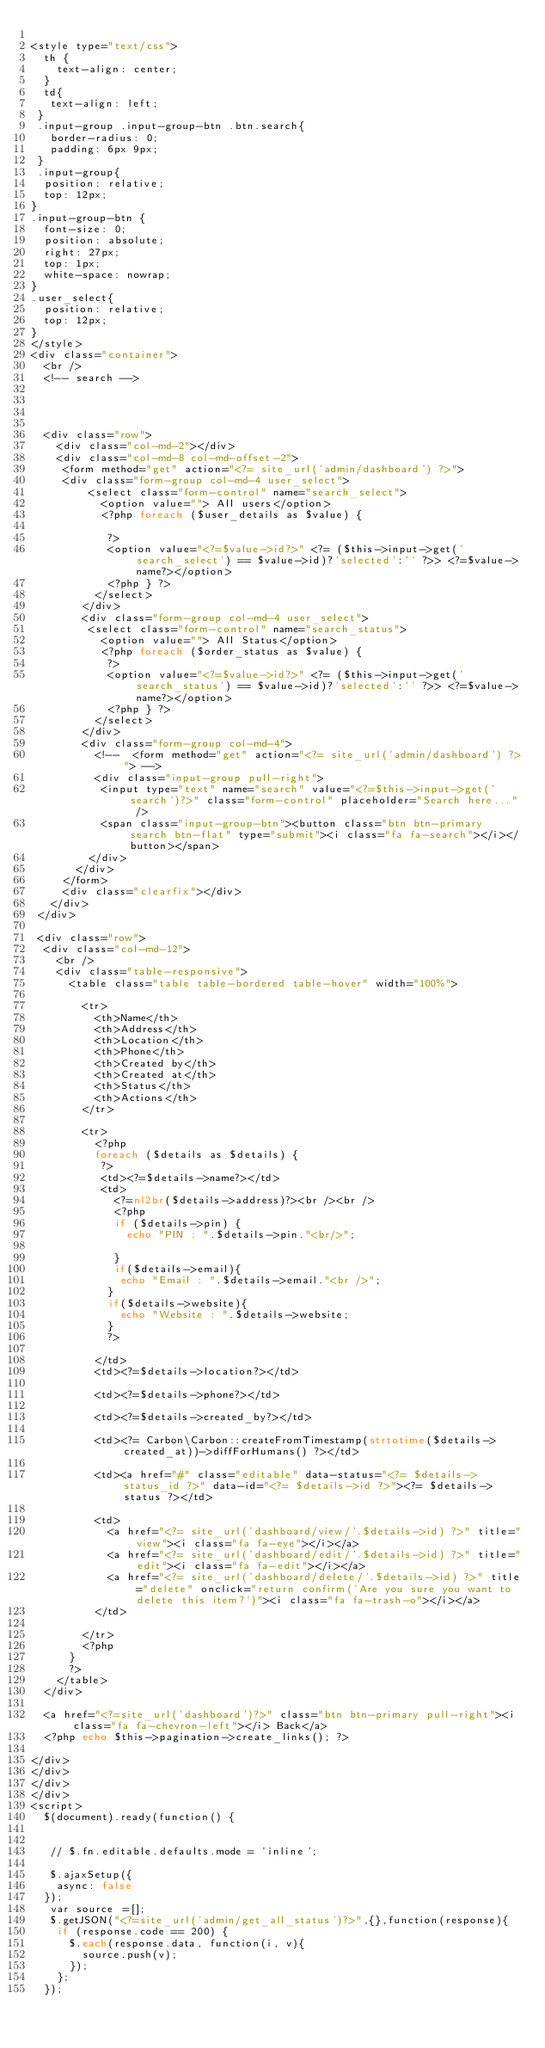<code> <loc_0><loc_0><loc_500><loc_500><_PHP_>
<style type="text/css">
  th {
    text-align: center;
  }
  td{
   text-align: left;
 }
 .input-group .input-group-btn .btn.search{
   border-radius: 0;
   padding: 6px 9px;
 }
 .input-group{
  position: relative;
  top: 12px;
}
.input-group-btn {
  font-size: 0;
  position: absolute;
  right: 27px;
  top: 1px;
  white-space: nowrap;
}
.user_select{
  position: relative;
  top: 12px;
}
</style>
<div class="container">
  <br />
  <!-- search -->




  <div class="row">
    <div class="col-md-2"></div>
    <div class="col-md-8 col-md-offset-2">
     <form method="get" action="<?= site_url('admin/dashboard') ?>">
     <div class="form-group col-md-4 user_select">
         <select class="form-control" name="search_select">
           <option value=""> All users</option>
           <?php foreach ($user_details as $value) {

            ?>
            <option value="<?=$value->id?>" <?= ($this->input->get('search_select') == $value->id)?'selected':'' ?>> <?=$value->name?></option>
            <?php } ?>
          </select>
        </div>
        <div class="form-group col-md-4 user_select">
         <select class="form-control" name="search_status">
           <option value=""> All Status</option>
           <?php foreach ($order_status as $value) {
            ?>
            <option value="<?=$value->id?>" <?= ($this->input->get('search_status') == $value->id)?'selected':'' ?>> <?=$value->name?></option>
            <?php } ?>
          </select>
        </div>
        <div class="form-group col-md-4">
          <!--  <form method="get" action="<?= site_url('admin/dashboard') ?>"> -->
          <div class="input-group pull-right">
           <input type="text" name="search" value="<?=$this->input->get('search')?>" class="form-control" placeholder="Search here..." />
           <span class="input-group-btn"><button class="btn btn-primary search btn-flat" type="submit"><i class="fa fa-search"></i></button></span>
         </div>
       </div>
     </form>
     <div class="clearfix"></div>
   </div>
 </div>

 <div class="row">
  <div class="col-md-12">
    <br />
    <div class="table-responsive">
      <table class="table table-bordered table-hover" width="100%">

        <tr>
          <th>Name</th>
          <th>Address</th>
          <th>Location</th>
          <th>Phone</th>
          <th>Created by</th>
          <th>Created at</th>
          <th>Status</th>
          <th>Actions</th>
        </tr>

        <tr>
          <?php
          foreach ($details as $details) {
           ?>
           <td><?=$details->name?></td>
           <td>
             <?=nl2br($details->address)?><br /><br />
             <?php
             if ($details->pin) {
               echo "PIN : ".$details->pin."<br/>";

             }
             if($details->email){
              echo "Email : ".$details->email."<br />";
            }
            if($details->website){
              echo "Website : ".$details->website;
            }
            ?>

          </td>
          <td><?=$details->location?></td>

          <td><?=$details->phone?></td>

          <td><?=$details->created_by?></td>

          <td><?= Carbon\Carbon::createFromTimestamp(strtotime($details->created_at))->diffForHumans() ?></td>

          <td><a href="#" class="editable" data-status="<?= $details->status_id ?>" data-id="<?= $details->id ?>"><?= $details->status ?></td>

          <td>
            <a href="<?= site_url('dashboard/view/'.$details->id) ?>" title="view"><i class="fa fa-eye"></i></a>
            <a href="<?= site_url('dashboard/edit/'.$details->id) ?>" title="edit"><i class="fa fa-edit"></i></a>
            <a href="<?= site_url('dashboard/delete/'.$details->id) ?>" title="delete" onclick="return confirm('Are you sure you want to delete this item?')"><i class="fa fa-trash-o"></i></a>
          </td>

        </tr>
        <?php
      }
      ?>
    </table>
  </div>

  <a href="<?=site_url('dashboard')?>" class="btn btn-primary pull-right"><i class="fa fa-chevron-left"></i> Back</a>
  <?php echo $this->pagination->create_links(); ?>

</div>
</div>
</div>
</div>
<script>
  $(document).ready(function() {


   // $.fn.editable.defaults.mode = 'inline';
   
   $.ajaxSetup({
    async: false
  });
   var source =[];
   $.getJSON("<?=site_url('admin/get_all_status')?>",{},function(response){
    if (response.code == 200) {
      $.each(response.data, function(i, v){
        source.push(v);
      });
    };
  });
</code> 